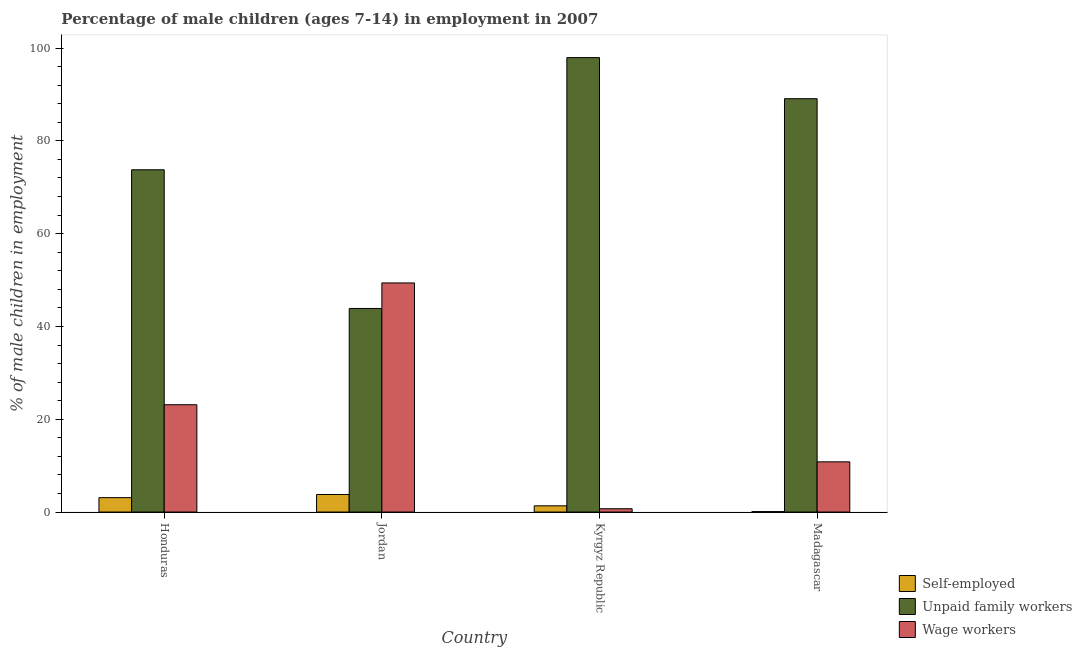How many different coloured bars are there?
Your answer should be very brief. 3. Are the number of bars per tick equal to the number of legend labels?
Offer a terse response. Yes. How many bars are there on the 2nd tick from the right?
Offer a terse response. 3. What is the label of the 3rd group of bars from the left?
Your answer should be compact. Kyrgyz Republic. In how many cases, is the number of bars for a given country not equal to the number of legend labels?
Your response must be concise. 0. What is the percentage of children employed as wage workers in Honduras?
Your answer should be very brief. 23.13. Across all countries, what is the maximum percentage of children employed as unpaid family workers?
Give a very brief answer. 97.95. Across all countries, what is the minimum percentage of children employed as wage workers?
Your answer should be compact. 0.71. In which country was the percentage of children employed as wage workers maximum?
Your answer should be very brief. Jordan. In which country was the percentage of children employed as unpaid family workers minimum?
Give a very brief answer. Jordan. What is the total percentage of self employed children in the graph?
Your response must be concise. 8.32. What is the difference between the percentage of children employed as wage workers in Kyrgyz Republic and that in Madagascar?
Your answer should be compact. -10.11. What is the difference between the percentage of self employed children in Kyrgyz Republic and the percentage of children employed as wage workers in Jordan?
Provide a short and direct response. -48.04. What is the average percentage of children employed as unpaid family workers per country?
Offer a very short reply. 76.17. What is the difference between the percentage of children employed as wage workers and percentage of self employed children in Kyrgyz Republic?
Your response must be concise. -0.63. In how many countries, is the percentage of children employed as unpaid family workers greater than 56 %?
Offer a very short reply. 3. What is the ratio of the percentage of children employed as wage workers in Honduras to that in Madagascar?
Your response must be concise. 2.14. Is the percentage of children employed as wage workers in Jordan less than that in Madagascar?
Offer a very short reply. No. What is the difference between the highest and the second highest percentage of children employed as unpaid family workers?
Provide a short and direct response. 8.86. What is the difference between the highest and the lowest percentage of children employed as wage workers?
Give a very brief answer. 48.67. In how many countries, is the percentage of self employed children greater than the average percentage of self employed children taken over all countries?
Give a very brief answer. 2. Is the sum of the percentage of self employed children in Honduras and Kyrgyz Republic greater than the maximum percentage of children employed as wage workers across all countries?
Offer a terse response. No. What does the 1st bar from the left in Kyrgyz Republic represents?
Give a very brief answer. Self-employed. What does the 2nd bar from the right in Honduras represents?
Give a very brief answer. Unpaid family workers. Is it the case that in every country, the sum of the percentage of self employed children and percentage of children employed as unpaid family workers is greater than the percentage of children employed as wage workers?
Ensure brevity in your answer.  No. Are the values on the major ticks of Y-axis written in scientific E-notation?
Offer a very short reply. No. Does the graph contain grids?
Provide a succinct answer. No. How many legend labels are there?
Your answer should be very brief. 3. How are the legend labels stacked?
Keep it short and to the point. Vertical. What is the title of the graph?
Ensure brevity in your answer.  Percentage of male children (ages 7-14) in employment in 2007. Does "Non-communicable diseases" appear as one of the legend labels in the graph?
Offer a terse response. No. What is the label or title of the X-axis?
Provide a succinct answer. Country. What is the label or title of the Y-axis?
Your answer should be compact. % of male children in employment. What is the % of male children in employment of Self-employed in Honduras?
Keep it short and to the point. 3.1. What is the % of male children in employment in Unpaid family workers in Honduras?
Your answer should be very brief. 73.77. What is the % of male children in employment of Wage workers in Honduras?
Keep it short and to the point. 23.13. What is the % of male children in employment of Self-employed in Jordan?
Offer a very short reply. 3.78. What is the % of male children in employment of Unpaid family workers in Jordan?
Provide a short and direct response. 43.88. What is the % of male children in employment of Wage workers in Jordan?
Ensure brevity in your answer.  49.38. What is the % of male children in employment of Self-employed in Kyrgyz Republic?
Make the answer very short. 1.34. What is the % of male children in employment in Unpaid family workers in Kyrgyz Republic?
Your answer should be compact. 97.95. What is the % of male children in employment of Wage workers in Kyrgyz Republic?
Give a very brief answer. 0.71. What is the % of male children in employment in Self-employed in Madagascar?
Ensure brevity in your answer.  0.1. What is the % of male children in employment of Unpaid family workers in Madagascar?
Offer a terse response. 89.09. What is the % of male children in employment in Wage workers in Madagascar?
Give a very brief answer. 10.82. Across all countries, what is the maximum % of male children in employment of Self-employed?
Your answer should be very brief. 3.78. Across all countries, what is the maximum % of male children in employment in Unpaid family workers?
Offer a terse response. 97.95. Across all countries, what is the maximum % of male children in employment in Wage workers?
Your response must be concise. 49.38. Across all countries, what is the minimum % of male children in employment of Self-employed?
Make the answer very short. 0.1. Across all countries, what is the minimum % of male children in employment of Unpaid family workers?
Your answer should be very brief. 43.88. Across all countries, what is the minimum % of male children in employment of Wage workers?
Offer a very short reply. 0.71. What is the total % of male children in employment in Self-employed in the graph?
Your answer should be compact. 8.32. What is the total % of male children in employment in Unpaid family workers in the graph?
Your answer should be compact. 304.69. What is the total % of male children in employment in Wage workers in the graph?
Offer a very short reply. 84.04. What is the difference between the % of male children in employment of Self-employed in Honduras and that in Jordan?
Keep it short and to the point. -0.68. What is the difference between the % of male children in employment of Unpaid family workers in Honduras and that in Jordan?
Offer a very short reply. 29.89. What is the difference between the % of male children in employment of Wage workers in Honduras and that in Jordan?
Offer a very short reply. -26.25. What is the difference between the % of male children in employment in Self-employed in Honduras and that in Kyrgyz Republic?
Give a very brief answer. 1.76. What is the difference between the % of male children in employment in Unpaid family workers in Honduras and that in Kyrgyz Republic?
Your response must be concise. -24.18. What is the difference between the % of male children in employment of Wage workers in Honduras and that in Kyrgyz Republic?
Offer a very short reply. 22.42. What is the difference between the % of male children in employment of Self-employed in Honduras and that in Madagascar?
Offer a very short reply. 3. What is the difference between the % of male children in employment in Unpaid family workers in Honduras and that in Madagascar?
Ensure brevity in your answer.  -15.32. What is the difference between the % of male children in employment of Wage workers in Honduras and that in Madagascar?
Make the answer very short. 12.31. What is the difference between the % of male children in employment in Self-employed in Jordan and that in Kyrgyz Republic?
Make the answer very short. 2.44. What is the difference between the % of male children in employment of Unpaid family workers in Jordan and that in Kyrgyz Republic?
Offer a terse response. -54.07. What is the difference between the % of male children in employment of Wage workers in Jordan and that in Kyrgyz Republic?
Provide a short and direct response. 48.67. What is the difference between the % of male children in employment in Self-employed in Jordan and that in Madagascar?
Offer a terse response. 3.68. What is the difference between the % of male children in employment in Unpaid family workers in Jordan and that in Madagascar?
Keep it short and to the point. -45.21. What is the difference between the % of male children in employment of Wage workers in Jordan and that in Madagascar?
Provide a succinct answer. 38.56. What is the difference between the % of male children in employment in Self-employed in Kyrgyz Republic and that in Madagascar?
Your response must be concise. 1.24. What is the difference between the % of male children in employment of Unpaid family workers in Kyrgyz Republic and that in Madagascar?
Make the answer very short. 8.86. What is the difference between the % of male children in employment of Wage workers in Kyrgyz Republic and that in Madagascar?
Ensure brevity in your answer.  -10.11. What is the difference between the % of male children in employment of Self-employed in Honduras and the % of male children in employment of Unpaid family workers in Jordan?
Offer a terse response. -40.78. What is the difference between the % of male children in employment of Self-employed in Honduras and the % of male children in employment of Wage workers in Jordan?
Your answer should be very brief. -46.28. What is the difference between the % of male children in employment of Unpaid family workers in Honduras and the % of male children in employment of Wage workers in Jordan?
Your answer should be compact. 24.39. What is the difference between the % of male children in employment of Self-employed in Honduras and the % of male children in employment of Unpaid family workers in Kyrgyz Republic?
Ensure brevity in your answer.  -94.85. What is the difference between the % of male children in employment of Self-employed in Honduras and the % of male children in employment of Wage workers in Kyrgyz Republic?
Offer a very short reply. 2.39. What is the difference between the % of male children in employment in Unpaid family workers in Honduras and the % of male children in employment in Wage workers in Kyrgyz Republic?
Keep it short and to the point. 73.06. What is the difference between the % of male children in employment in Self-employed in Honduras and the % of male children in employment in Unpaid family workers in Madagascar?
Your response must be concise. -85.99. What is the difference between the % of male children in employment in Self-employed in Honduras and the % of male children in employment in Wage workers in Madagascar?
Make the answer very short. -7.72. What is the difference between the % of male children in employment of Unpaid family workers in Honduras and the % of male children in employment of Wage workers in Madagascar?
Ensure brevity in your answer.  62.95. What is the difference between the % of male children in employment in Self-employed in Jordan and the % of male children in employment in Unpaid family workers in Kyrgyz Republic?
Provide a short and direct response. -94.17. What is the difference between the % of male children in employment of Self-employed in Jordan and the % of male children in employment of Wage workers in Kyrgyz Republic?
Keep it short and to the point. 3.07. What is the difference between the % of male children in employment of Unpaid family workers in Jordan and the % of male children in employment of Wage workers in Kyrgyz Republic?
Your answer should be compact. 43.17. What is the difference between the % of male children in employment of Self-employed in Jordan and the % of male children in employment of Unpaid family workers in Madagascar?
Keep it short and to the point. -85.31. What is the difference between the % of male children in employment of Self-employed in Jordan and the % of male children in employment of Wage workers in Madagascar?
Provide a succinct answer. -7.04. What is the difference between the % of male children in employment of Unpaid family workers in Jordan and the % of male children in employment of Wage workers in Madagascar?
Keep it short and to the point. 33.06. What is the difference between the % of male children in employment in Self-employed in Kyrgyz Republic and the % of male children in employment in Unpaid family workers in Madagascar?
Provide a short and direct response. -87.75. What is the difference between the % of male children in employment of Self-employed in Kyrgyz Republic and the % of male children in employment of Wage workers in Madagascar?
Provide a short and direct response. -9.48. What is the difference between the % of male children in employment of Unpaid family workers in Kyrgyz Republic and the % of male children in employment of Wage workers in Madagascar?
Give a very brief answer. 87.13. What is the average % of male children in employment in Self-employed per country?
Offer a terse response. 2.08. What is the average % of male children in employment in Unpaid family workers per country?
Keep it short and to the point. 76.17. What is the average % of male children in employment of Wage workers per country?
Provide a succinct answer. 21.01. What is the difference between the % of male children in employment in Self-employed and % of male children in employment in Unpaid family workers in Honduras?
Keep it short and to the point. -70.67. What is the difference between the % of male children in employment of Self-employed and % of male children in employment of Wage workers in Honduras?
Make the answer very short. -20.03. What is the difference between the % of male children in employment in Unpaid family workers and % of male children in employment in Wage workers in Honduras?
Your answer should be very brief. 50.64. What is the difference between the % of male children in employment in Self-employed and % of male children in employment in Unpaid family workers in Jordan?
Provide a short and direct response. -40.1. What is the difference between the % of male children in employment in Self-employed and % of male children in employment in Wage workers in Jordan?
Provide a succinct answer. -45.6. What is the difference between the % of male children in employment in Unpaid family workers and % of male children in employment in Wage workers in Jordan?
Provide a short and direct response. -5.5. What is the difference between the % of male children in employment of Self-employed and % of male children in employment of Unpaid family workers in Kyrgyz Republic?
Offer a terse response. -96.61. What is the difference between the % of male children in employment of Self-employed and % of male children in employment of Wage workers in Kyrgyz Republic?
Your answer should be compact. 0.63. What is the difference between the % of male children in employment in Unpaid family workers and % of male children in employment in Wage workers in Kyrgyz Republic?
Your answer should be compact. 97.24. What is the difference between the % of male children in employment of Self-employed and % of male children in employment of Unpaid family workers in Madagascar?
Offer a terse response. -88.99. What is the difference between the % of male children in employment of Self-employed and % of male children in employment of Wage workers in Madagascar?
Your answer should be very brief. -10.72. What is the difference between the % of male children in employment of Unpaid family workers and % of male children in employment of Wage workers in Madagascar?
Provide a succinct answer. 78.27. What is the ratio of the % of male children in employment in Self-employed in Honduras to that in Jordan?
Provide a succinct answer. 0.82. What is the ratio of the % of male children in employment in Unpaid family workers in Honduras to that in Jordan?
Your answer should be very brief. 1.68. What is the ratio of the % of male children in employment of Wage workers in Honduras to that in Jordan?
Your answer should be very brief. 0.47. What is the ratio of the % of male children in employment of Self-employed in Honduras to that in Kyrgyz Republic?
Keep it short and to the point. 2.31. What is the ratio of the % of male children in employment of Unpaid family workers in Honduras to that in Kyrgyz Republic?
Your answer should be compact. 0.75. What is the ratio of the % of male children in employment in Wage workers in Honduras to that in Kyrgyz Republic?
Make the answer very short. 32.58. What is the ratio of the % of male children in employment in Unpaid family workers in Honduras to that in Madagascar?
Your answer should be compact. 0.83. What is the ratio of the % of male children in employment in Wage workers in Honduras to that in Madagascar?
Make the answer very short. 2.14. What is the ratio of the % of male children in employment of Self-employed in Jordan to that in Kyrgyz Republic?
Your answer should be compact. 2.82. What is the ratio of the % of male children in employment of Unpaid family workers in Jordan to that in Kyrgyz Republic?
Give a very brief answer. 0.45. What is the ratio of the % of male children in employment in Wage workers in Jordan to that in Kyrgyz Republic?
Provide a short and direct response. 69.55. What is the ratio of the % of male children in employment in Self-employed in Jordan to that in Madagascar?
Your response must be concise. 37.8. What is the ratio of the % of male children in employment in Unpaid family workers in Jordan to that in Madagascar?
Your answer should be compact. 0.49. What is the ratio of the % of male children in employment in Wage workers in Jordan to that in Madagascar?
Provide a succinct answer. 4.56. What is the ratio of the % of male children in employment in Self-employed in Kyrgyz Republic to that in Madagascar?
Make the answer very short. 13.4. What is the ratio of the % of male children in employment of Unpaid family workers in Kyrgyz Republic to that in Madagascar?
Give a very brief answer. 1.1. What is the ratio of the % of male children in employment of Wage workers in Kyrgyz Republic to that in Madagascar?
Ensure brevity in your answer.  0.07. What is the difference between the highest and the second highest % of male children in employment of Self-employed?
Make the answer very short. 0.68. What is the difference between the highest and the second highest % of male children in employment of Unpaid family workers?
Make the answer very short. 8.86. What is the difference between the highest and the second highest % of male children in employment in Wage workers?
Keep it short and to the point. 26.25. What is the difference between the highest and the lowest % of male children in employment in Self-employed?
Give a very brief answer. 3.68. What is the difference between the highest and the lowest % of male children in employment of Unpaid family workers?
Give a very brief answer. 54.07. What is the difference between the highest and the lowest % of male children in employment in Wage workers?
Offer a very short reply. 48.67. 